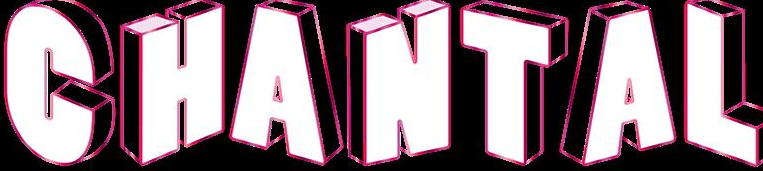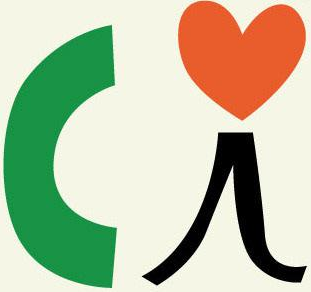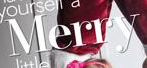What text is displayed in these images sequentially, separated by a semicolon? CHANTAL; Ci; Merry 